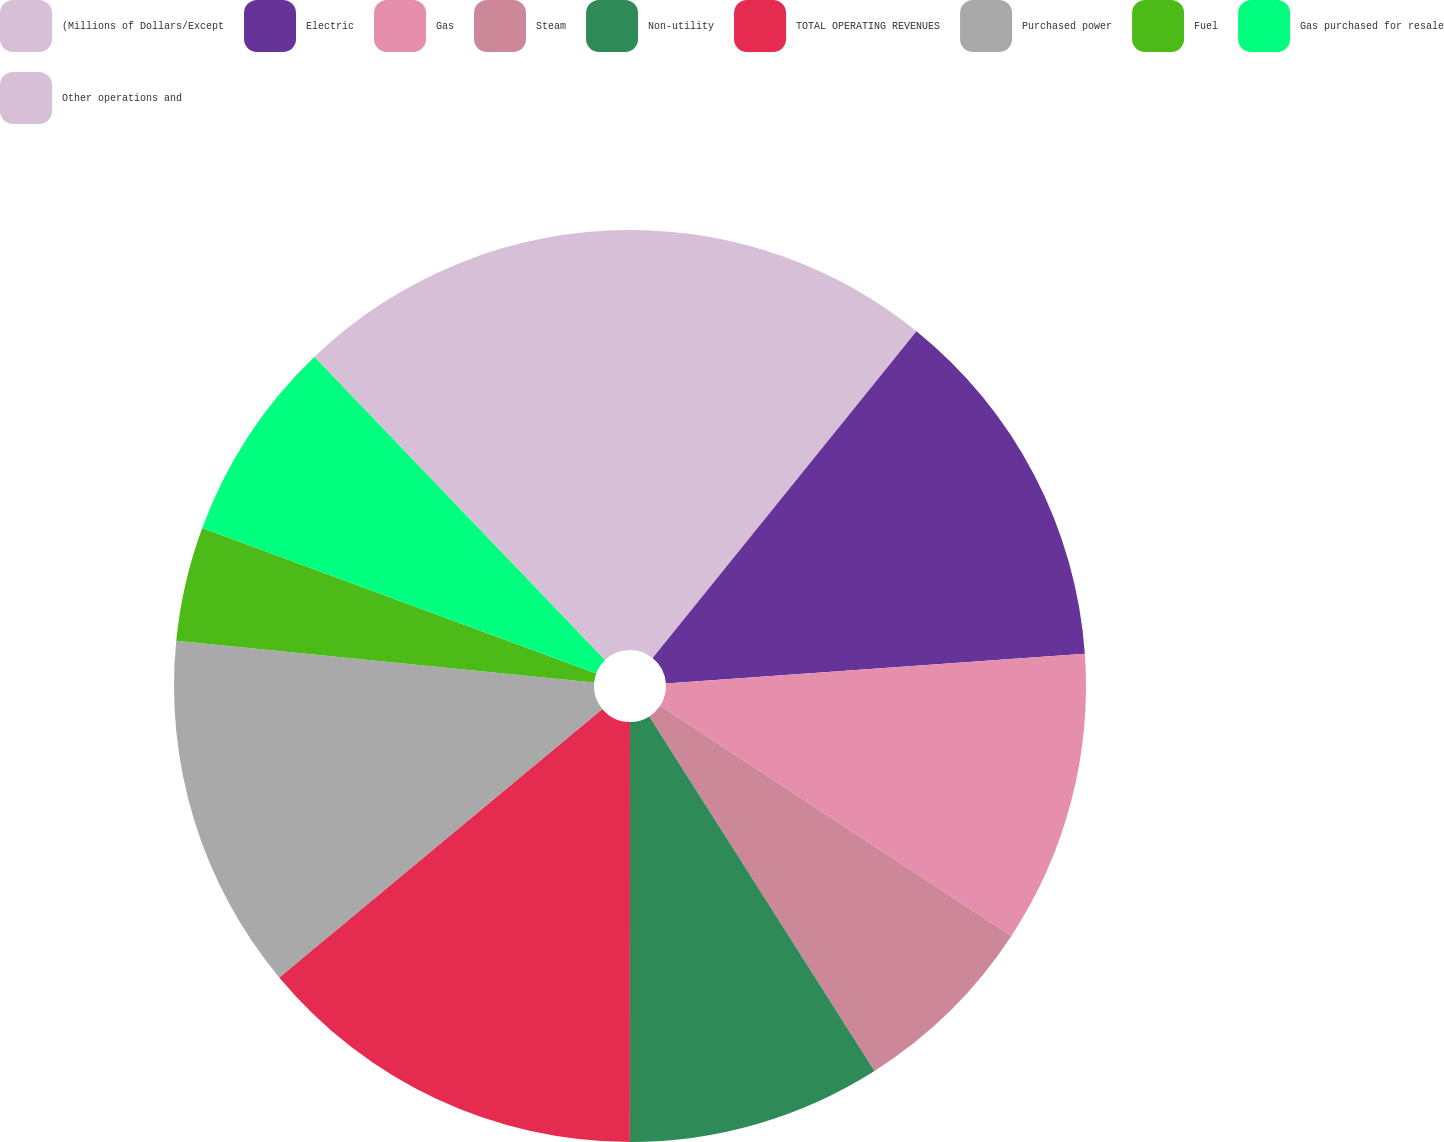Convert chart. <chart><loc_0><loc_0><loc_500><loc_500><pie_chart><fcel>(Millions of Dollars/Except<fcel>Electric<fcel>Gas<fcel>Steam<fcel>Non-utility<fcel>TOTAL OPERATING REVENUES<fcel>Purchased power<fcel>Fuel<fcel>Gas purchased for resale<fcel>Other operations and<nl><fcel>10.81%<fcel>13.06%<fcel>10.36%<fcel>6.76%<fcel>9.01%<fcel>13.96%<fcel>12.61%<fcel>4.05%<fcel>7.21%<fcel>12.16%<nl></chart> 